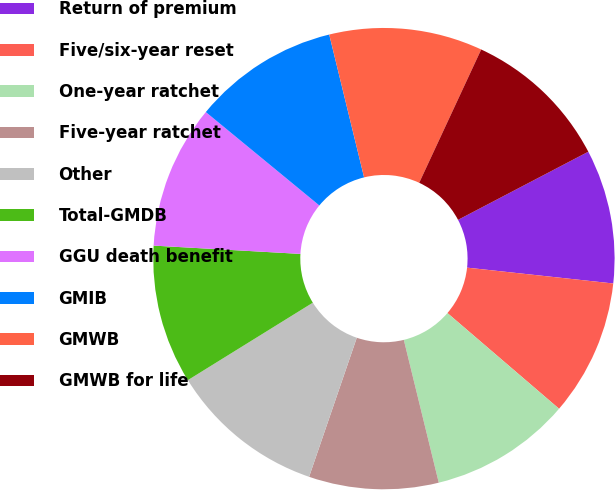<chart> <loc_0><loc_0><loc_500><loc_500><pie_chart><fcel>Return of premium<fcel>Five/six-year reset<fcel>One-year ratchet<fcel>Five-year ratchet<fcel>Other<fcel>Total-GMDB<fcel>GGU death benefit<fcel>GMIB<fcel>GMWB<fcel>GMWB for life<nl><fcel>9.39%<fcel>9.56%<fcel>9.9%<fcel>9.08%<fcel>10.91%<fcel>9.73%<fcel>10.06%<fcel>10.23%<fcel>10.74%<fcel>10.4%<nl></chart> 